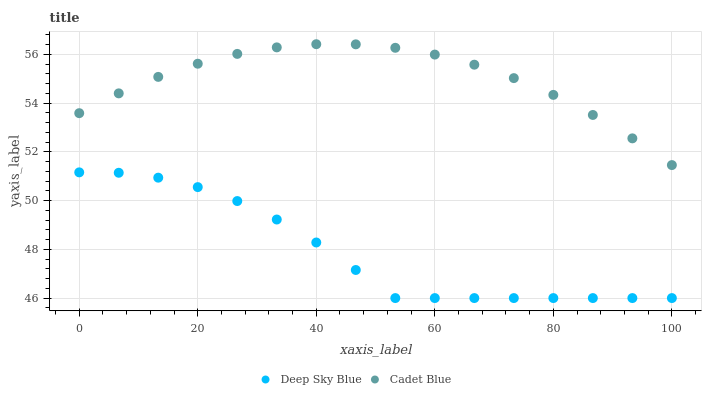Does Deep Sky Blue have the minimum area under the curve?
Answer yes or no. Yes. Does Cadet Blue have the maximum area under the curve?
Answer yes or no. Yes. Does Deep Sky Blue have the maximum area under the curve?
Answer yes or no. No. Is Cadet Blue the smoothest?
Answer yes or no. Yes. Is Deep Sky Blue the roughest?
Answer yes or no. Yes. Is Deep Sky Blue the smoothest?
Answer yes or no. No. Does Deep Sky Blue have the lowest value?
Answer yes or no. Yes. Does Cadet Blue have the highest value?
Answer yes or no. Yes. Does Deep Sky Blue have the highest value?
Answer yes or no. No. Is Deep Sky Blue less than Cadet Blue?
Answer yes or no. Yes. Is Cadet Blue greater than Deep Sky Blue?
Answer yes or no. Yes. Does Deep Sky Blue intersect Cadet Blue?
Answer yes or no. No. 